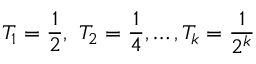Convert formula to latex. <formula><loc_0><loc_0><loc_500><loc_500>T _ { 1 } = { \frac { 1 } { 2 } } , \ T _ { 2 } = { \frac { 1 } { 4 } } , \dots , T _ { k } = { \frac { 1 } { 2 ^ { k } } }</formula> 